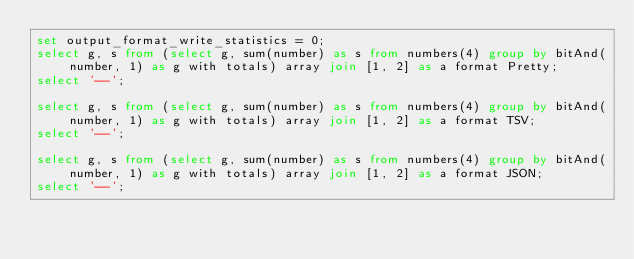<code> <loc_0><loc_0><loc_500><loc_500><_SQL_>set output_format_write_statistics = 0;
select g, s from (select g, sum(number) as s from numbers(4) group by bitAnd(number, 1) as g with totals) array join [1, 2] as a format Pretty;
select '--';

select g, s from (select g, sum(number) as s from numbers(4) group by bitAnd(number, 1) as g with totals) array join [1, 2] as a format TSV;
select '--';

select g, s from (select g, sum(number) as s from numbers(4) group by bitAnd(number, 1) as g with totals) array join [1, 2] as a format JSON;
select '--';
</code> 